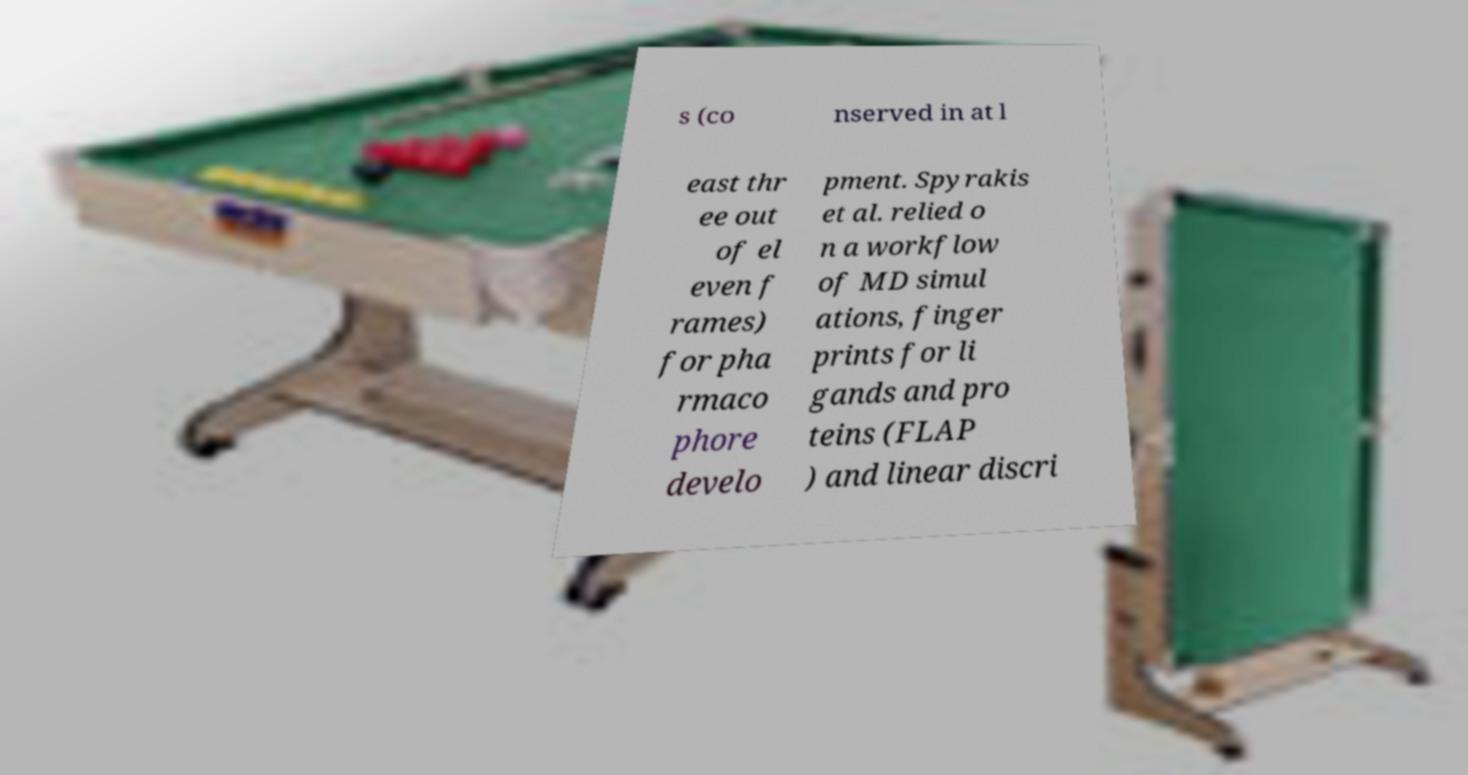Please identify and transcribe the text found in this image. s (co nserved in at l east thr ee out of el even f rames) for pha rmaco phore develo pment. Spyrakis et al. relied o n a workflow of MD simul ations, finger prints for li gands and pro teins (FLAP ) and linear discri 